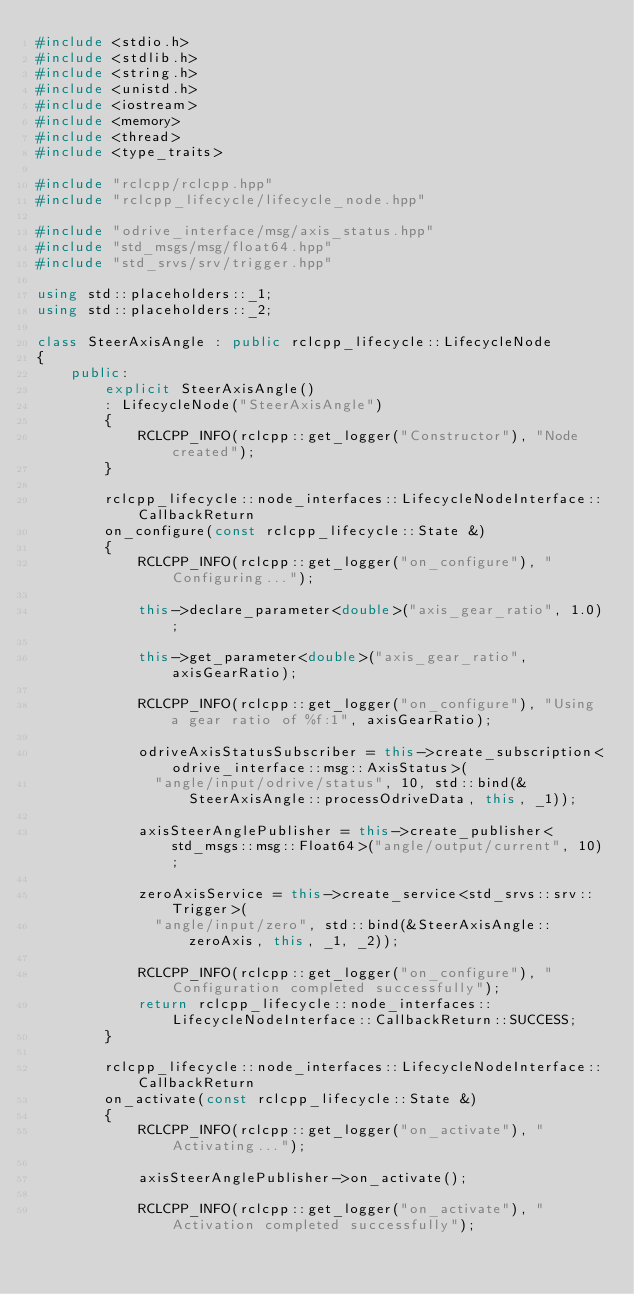<code> <loc_0><loc_0><loc_500><loc_500><_C++_>#include <stdio.h>
#include <stdlib.h>
#include <string.h>
#include <unistd.h>
#include <iostream>
#include <memory>
#include <thread>
#include <type_traits>

#include "rclcpp/rclcpp.hpp"
#include "rclcpp_lifecycle/lifecycle_node.hpp"

#include "odrive_interface/msg/axis_status.hpp"
#include "std_msgs/msg/float64.hpp"
#include "std_srvs/srv/trigger.hpp"

using std::placeholders::_1;
using std::placeholders::_2;

class SteerAxisAngle : public rclcpp_lifecycle::LifecycleNode
{
    public:
        explicit SteerAxisAngle()
        : LifecycleNode("SteerAxisAngle")
        {
            RCLCPP_INFO(rclcpp::get_logger("Constructor"), "Node created");
        }

        rclcpp_lifecycle::node_interfaces::LifecycleNodeInterface::CallbackReturn
        on_configure(const rclcpp_lifecycle::State &)
        {
            RCLCPP_INFO(rclcpp::get_logger("on_configure"), "Configuring...");

            this->declare_parameter<double>("axis_gear_ratio", 1.0);

            this->get_parameter<double>("axis_gear_ratio", axisGearRatio);

            RCLCPP_INFO(rclcpp::get_logger("on_configure"), "Using a gear ratio of %f:1", axisGearRatio);

            odriveAxisStatusSubscriber = this->create_subscription<odrive_interface::msg::AxisStatus>(
              "angle/input/odrive/status", 10, std::bind(&SteerAxisAngle::processOdriveData, this, _1));

            axisSteerAnglePublisher = this->create_publisher<std_msgs::msg::Float64>("angle/output/current", 10);

            zeroAxisService = this->create_service<std_srvs::srv::Trigger>(
              "angle/input/zero", std::bind(&SteerAxisAngle::zeroAxis, this, _1, _2));

            RCLCPP_INFO(rclcpp::get_logger("on_configure"), "Configuration completed successfully");
            return rclcpp_lifecycle::node_interfaces::LifecycleNodeInterface::CallbackReturn::SUCCESS;
        }

        rclcpp_lifecycle::node_interfaces::LifecycleNodeInterface::CallbackReturn
        on_activate(const rclcpp_lifecycle::State &)
        {
            RCLCPP_INFO(rclcpp::get_logger("on_activate"), "Activating...");

            axisSteerAnglePublisher->on_activate();

            RCLCPP_INFO(rclcpp::get_logger("on_activate"), "Activation completed successfully");
            </code> 